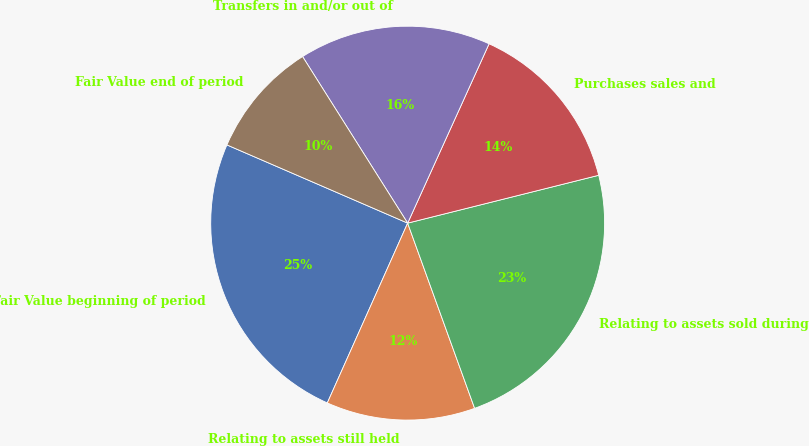Convert chart to OTSL. <chart><loc_0><loc_0><loc_500><loc_500><pie_chart><fcel>Fair Value beginning of period<fcel>Relating to assets still held<fcel>Relating to assets sold during<fcel>Purchases sales and<fcel>Transfers in and/or out of<fcel>Fair Value end of period<nl><fcel>24.81%<fcel>12.21%<fcel>23.38%<fcel>14.31%<fcel>15.74%<fcel>9.54%<nl></chart> 